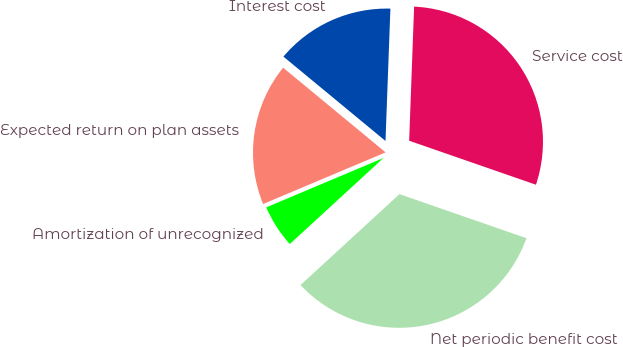<chart> <loc_0><loc_0><loc_500><loc_500><pie_chart><fcel>Service cost<fcel>Interest cost<fcel>Expected return on plan assets<fcel>Amortization of unrecognized<fcel>Net periodic benefit cost<nl><fcel>29.73%<fcel>14.6%<fcel>17.34%<fcel>5.48%<fcel>32.86%<nl></chart> 